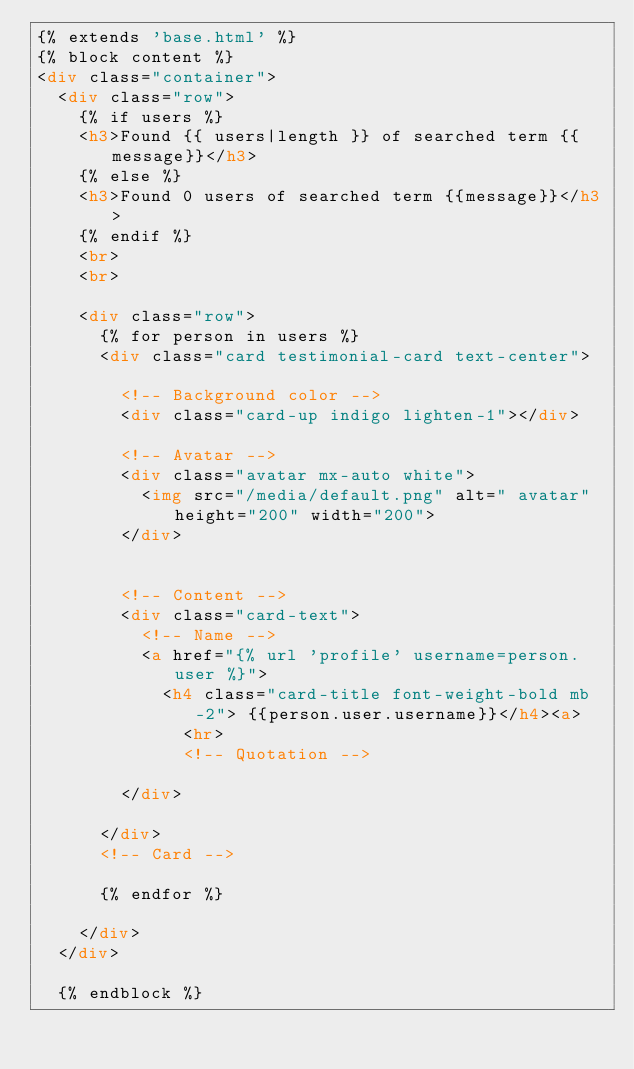Convert code to text. <code><loc_0><loc_0><loc_500><loc_500><_HTML_>{% extends 'base.html' %}
{% block content %}
<div class="container">
  <div class="row">
    {% if users %}
    <h3>Found {{ users|length }} of searched term {{message}}</h3>
    {% else %}
    <h3>Found 0 users of searched term {{message}}</h3>
    {% endif %}
    <br>
    <br>

    <div class="row">
      {% for person in users %}
      <div class="card testimonial-card text-center">

        <!-- Background color -->
        <div class="card-up indigo lighten-1"></div>

        <!-- Avatar -->
        <div class="avatar mx-auto white">
          <img src="/media/default.png" alt=" avatar" height="200" width="200">
        </div>


        <!-- Content -->
        <div class="card-text">
          <!-- Name -->
          <a href="{% url 'profile' username=person.user %}">
            <h4 class="card-title font-weight-bold mb-2"> {{person.user.username}}</h4><a>
              <hr>
              <!-- Quotation -->

        </div>

      </div>
      <!-- Card -->

      {% endfor %}

    </div>
  </div>

  {% endblock %}</code> 